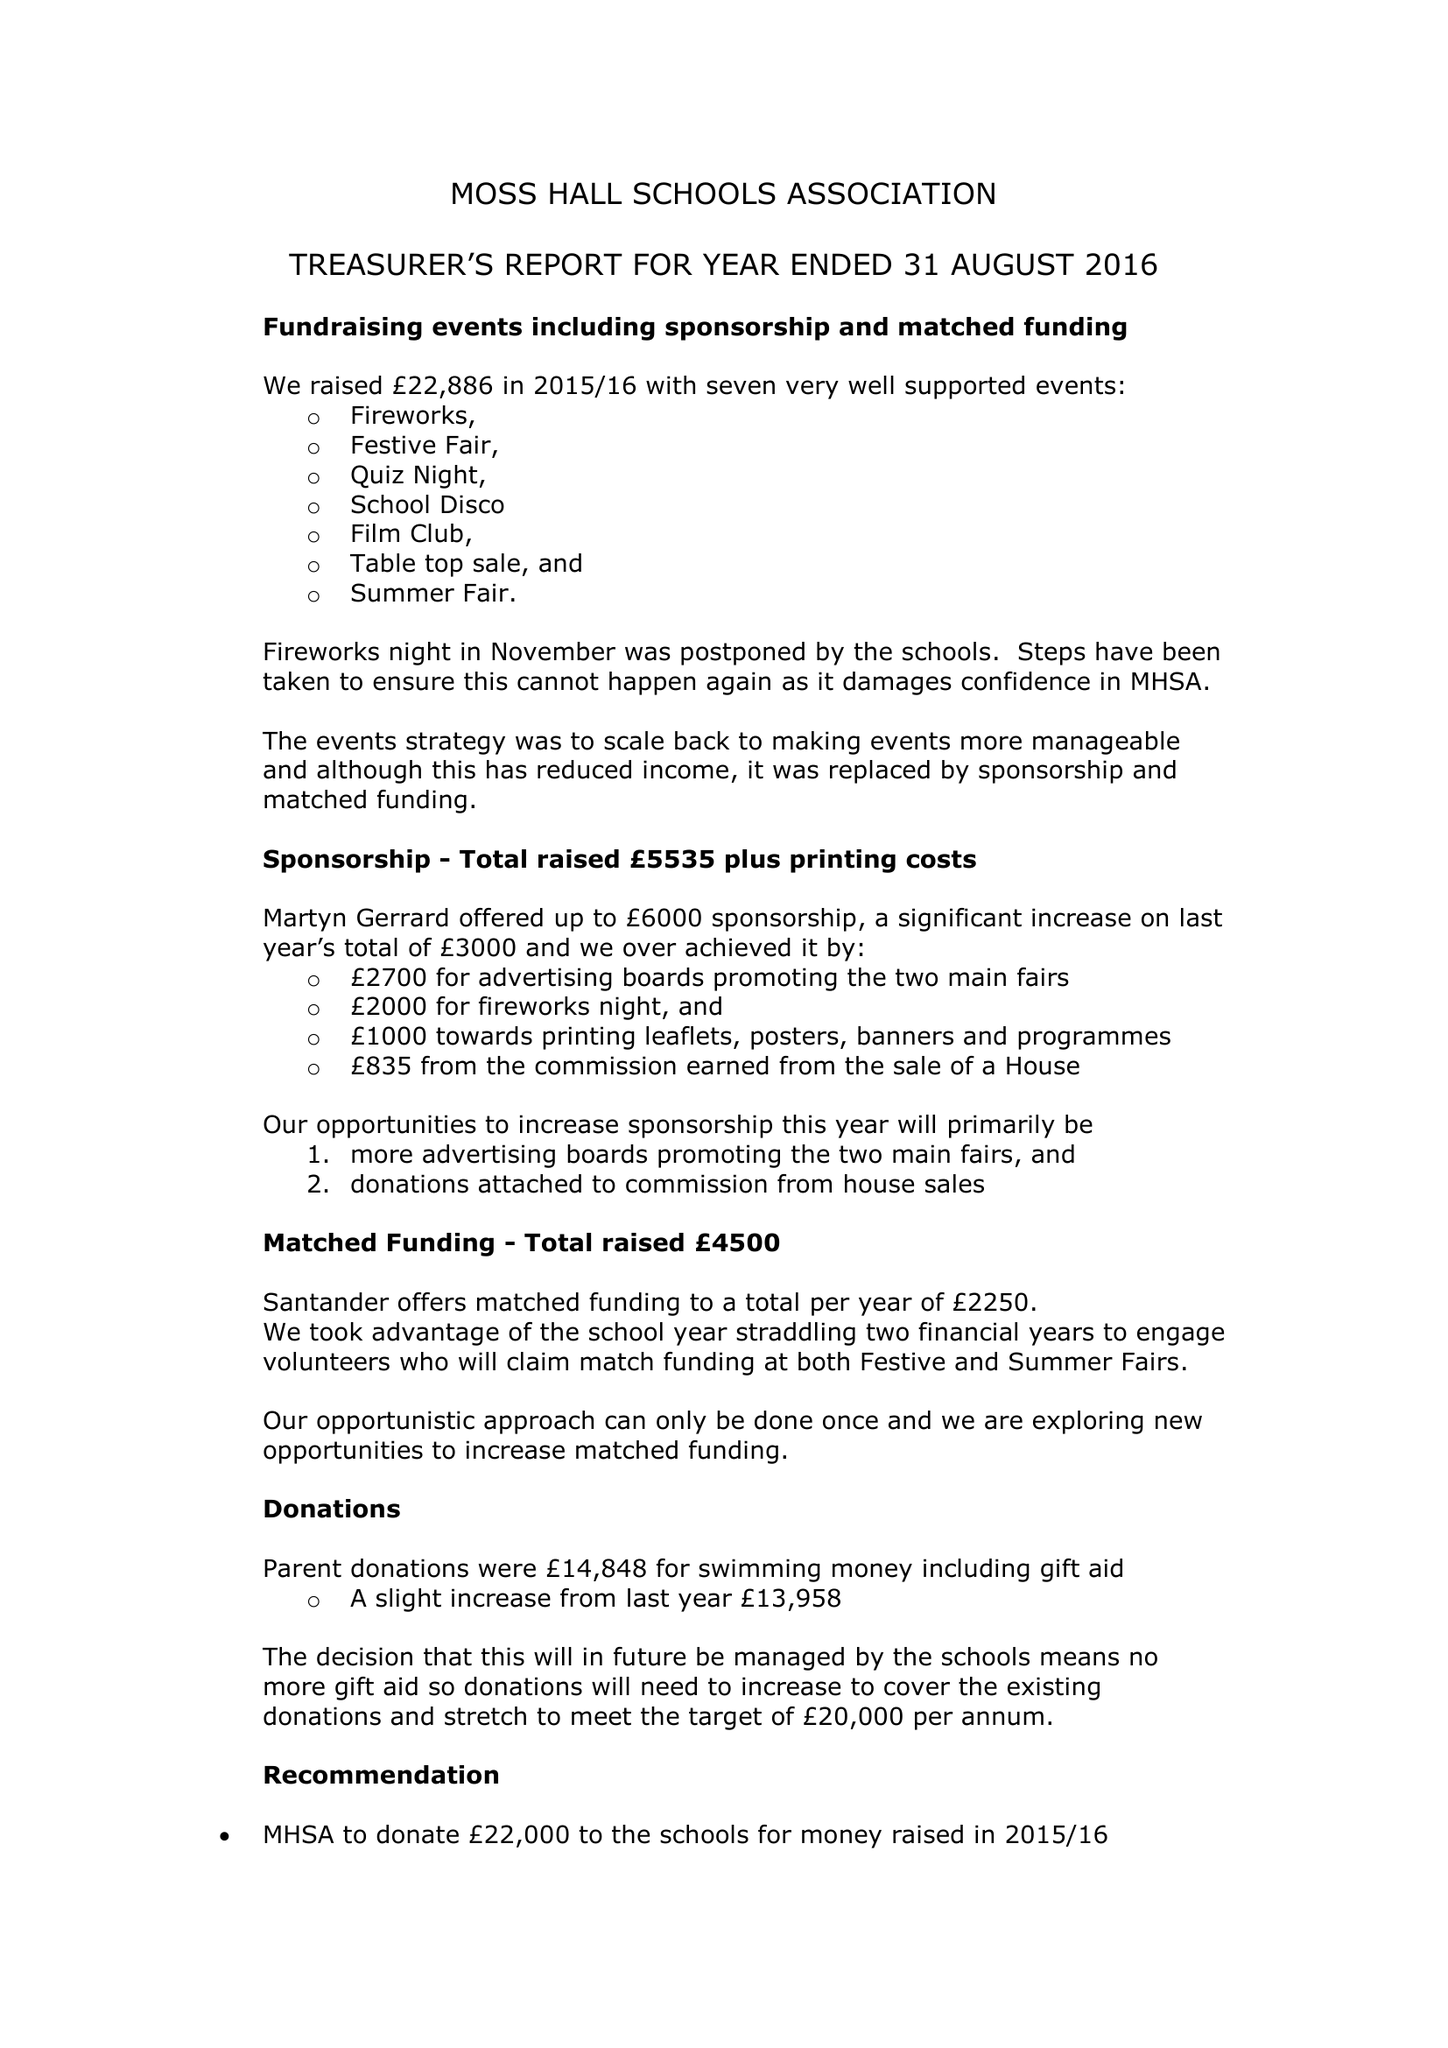What is the value for the spending_annually_in_british_pounds?
Answer the question using a single word or phrase. 10170.00 